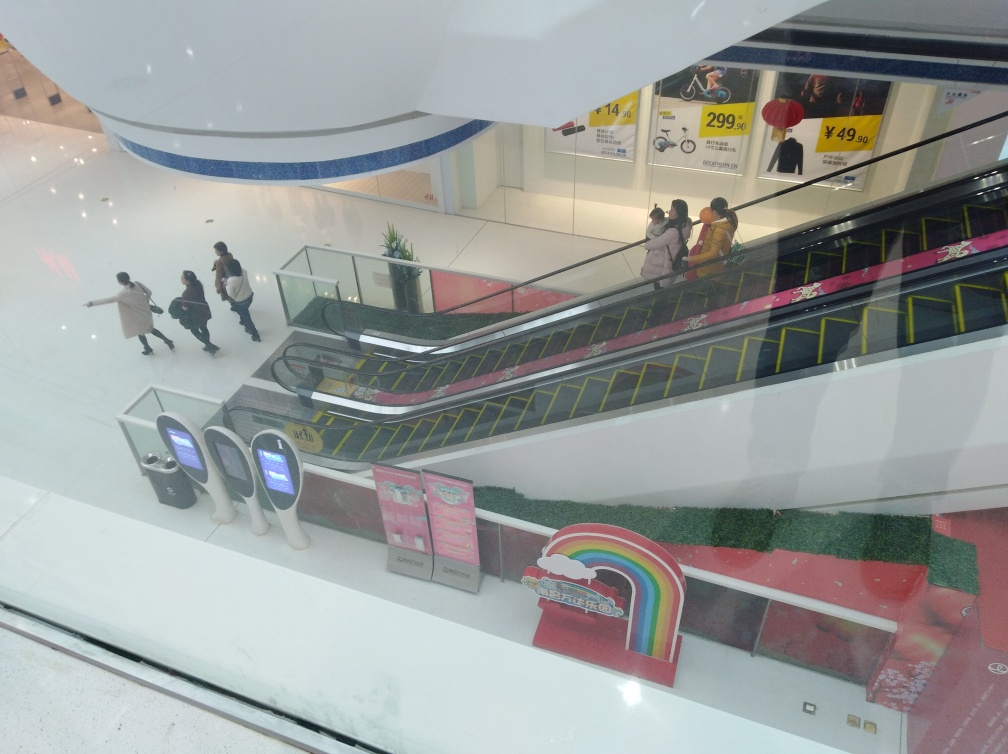Is the lighting in the image good? While the lighting in the image appears to be sufficient for visibility and captures the scene without stark shadows or overexposure, the quality can be subjective. Some may find it adequate for an indoor setting, though it does lack a certain warmth, which could be improved to create a more welcoming atmosphere. So, it is good in terms of functionality, but aesthetically it could be enhanced. 